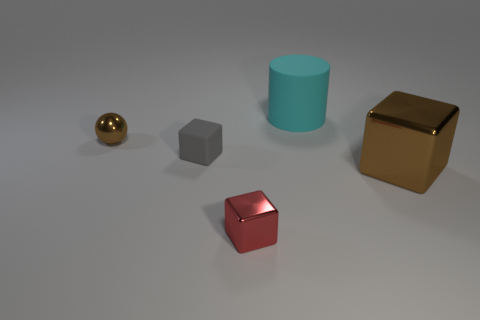What is the material of the big thing behind the tiny metal sphere in front of the cyan thing? Considering the visual cues in the image, the large object behind the tiny metal sphere appears to be a cube with a reflective surface, which suggests it could be made of metal or a polished stone, rather than rubber. Due to its golden hue and shiny reflection, it is likely to be a render of a gold-colored metal. 